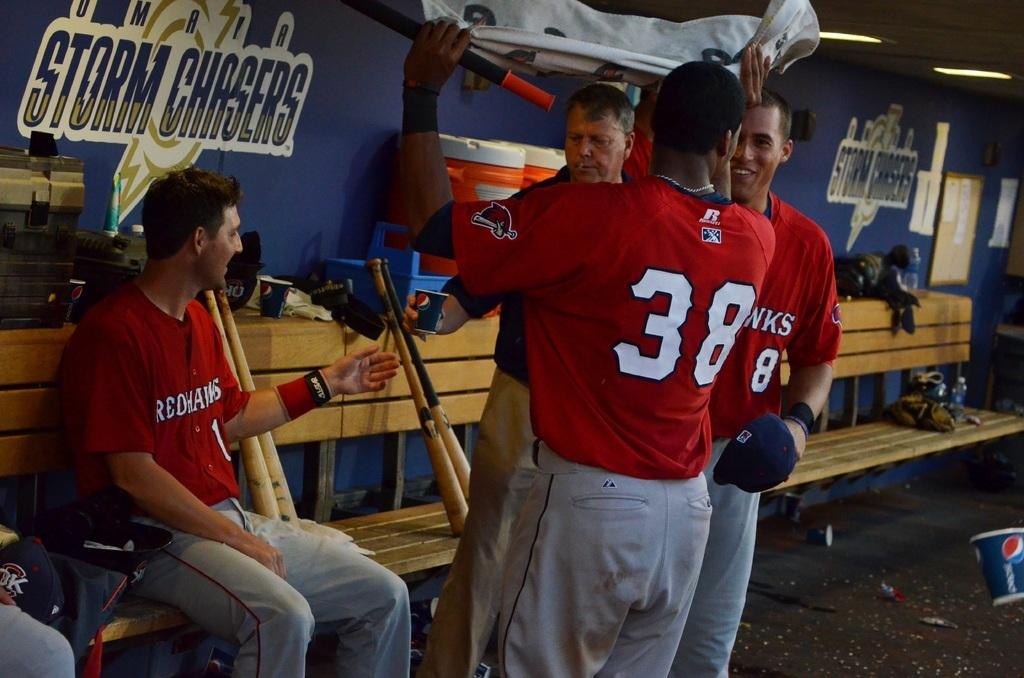<image>
Give a short and clear explanation of the subsequent image. A baseball team's uniforms identifies its players as the Redhawks. 